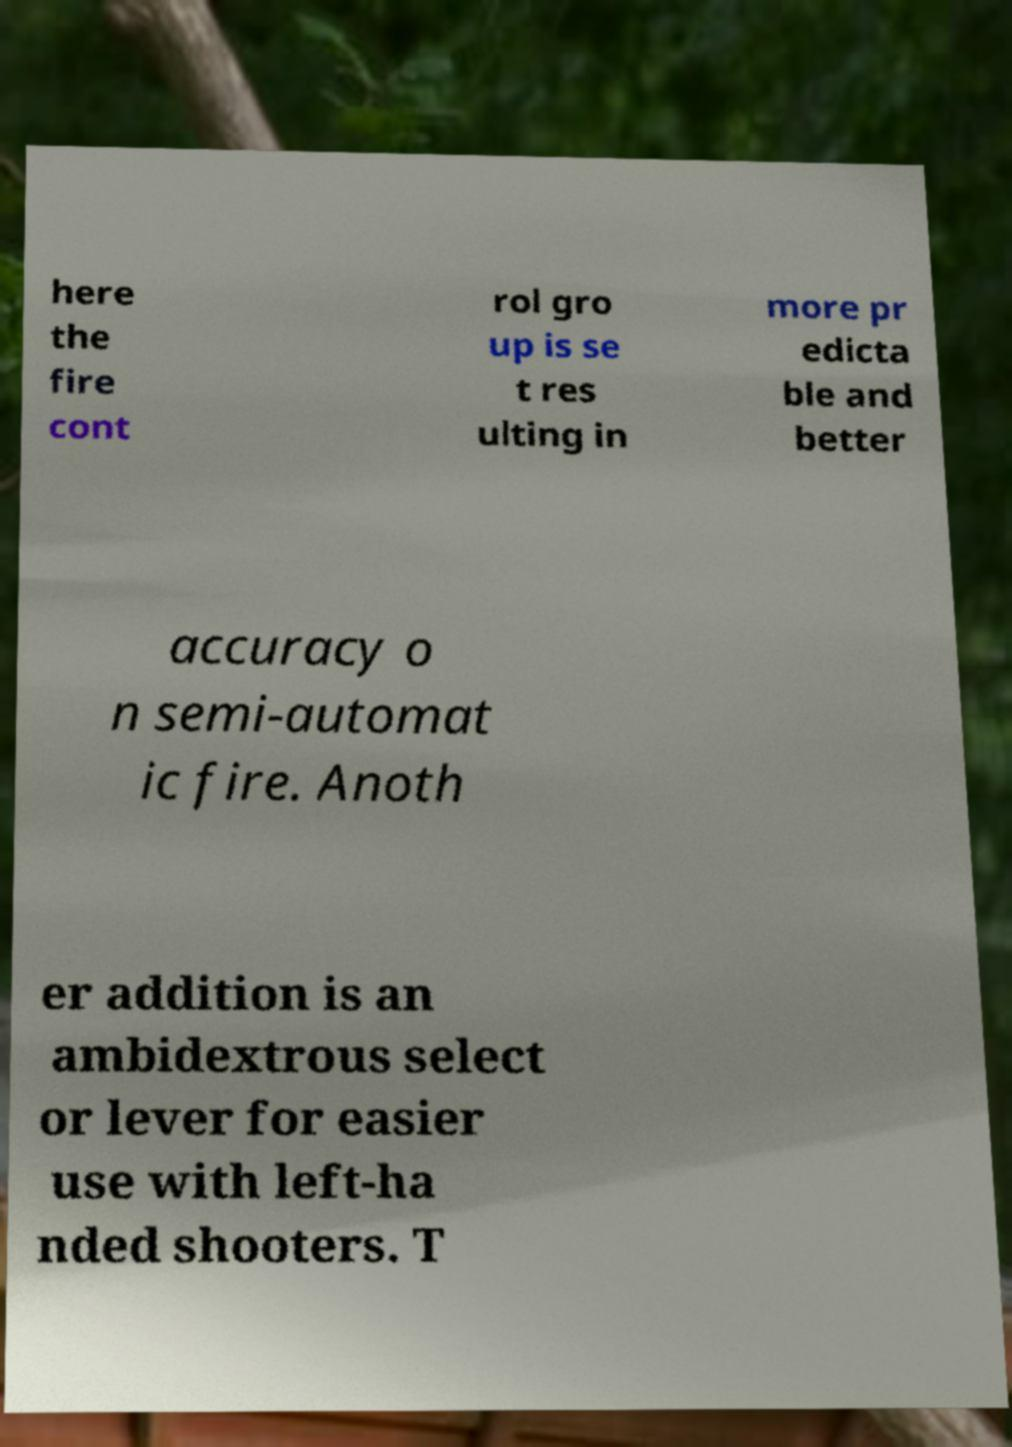I need the written content from this picture converted into text. Can you do that? here the fire cont rol gro up is se t res ulting in more pr edicta ble and better accuracy o n semi-automat ic fire. Anoth er addition is an ambidextrous select or lever for easier use with left-ha nded shooters. T 